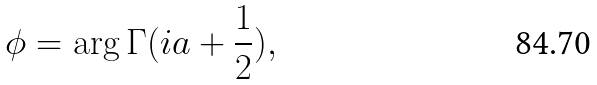<formula> <loc_0><loc_0><loc_500><loc_500>\phi = \arg { \Gamma ( i a + \frac { 1 } { 2 } ) } ,</formula> 